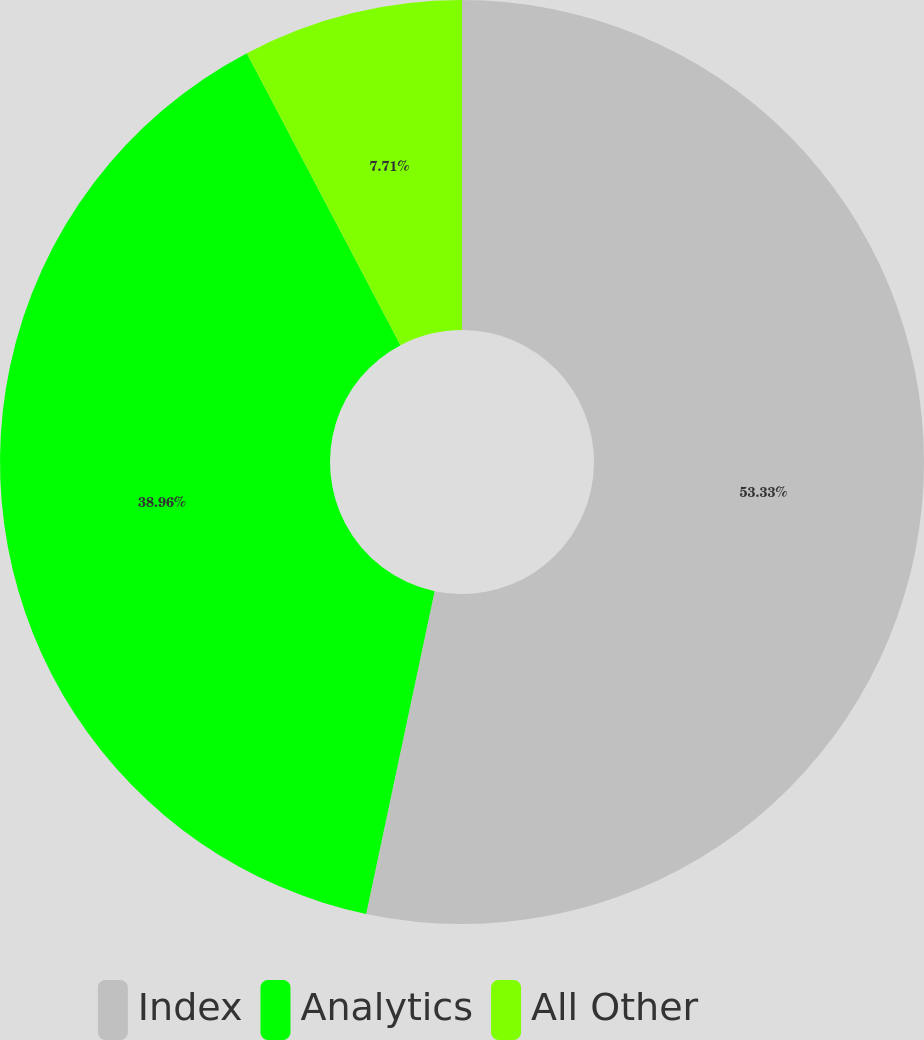Convert chart to OTSL. <chart><loc_0><loc_0><loc_500><loc_500><pie_chart><fcel>Index<fcel>Analytics<fcel>All Other<nl><fcel>53.32%<fcel>38.96%<fcel>7.71%<nl></chart> 